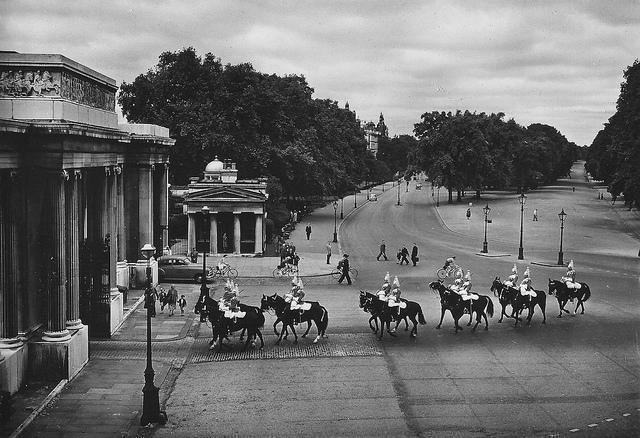What kind of building is it on the left?
Pick the right solution, then justify: 'Answer: answer
Rationale: rationale.'
Options: Hotel, government building, residential building, shopping mall. Answer: government building.
Rationale: The building is for the government. 